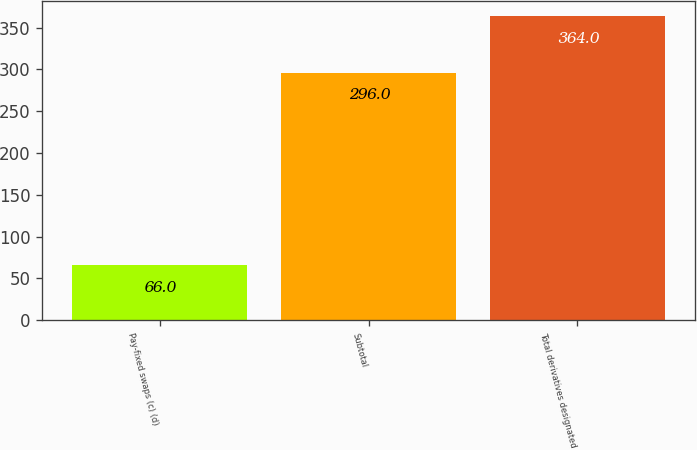Convert chart. <chart><loc_0><loc_0><loc_500><loc_500><bar_chart><fcel>Pay-fixed swaps (c) (d)<fcel>Subtotal<fcel>Total derivatives designated<nl><fcel>66<fcel>296<fcel>364<nl></chart> 